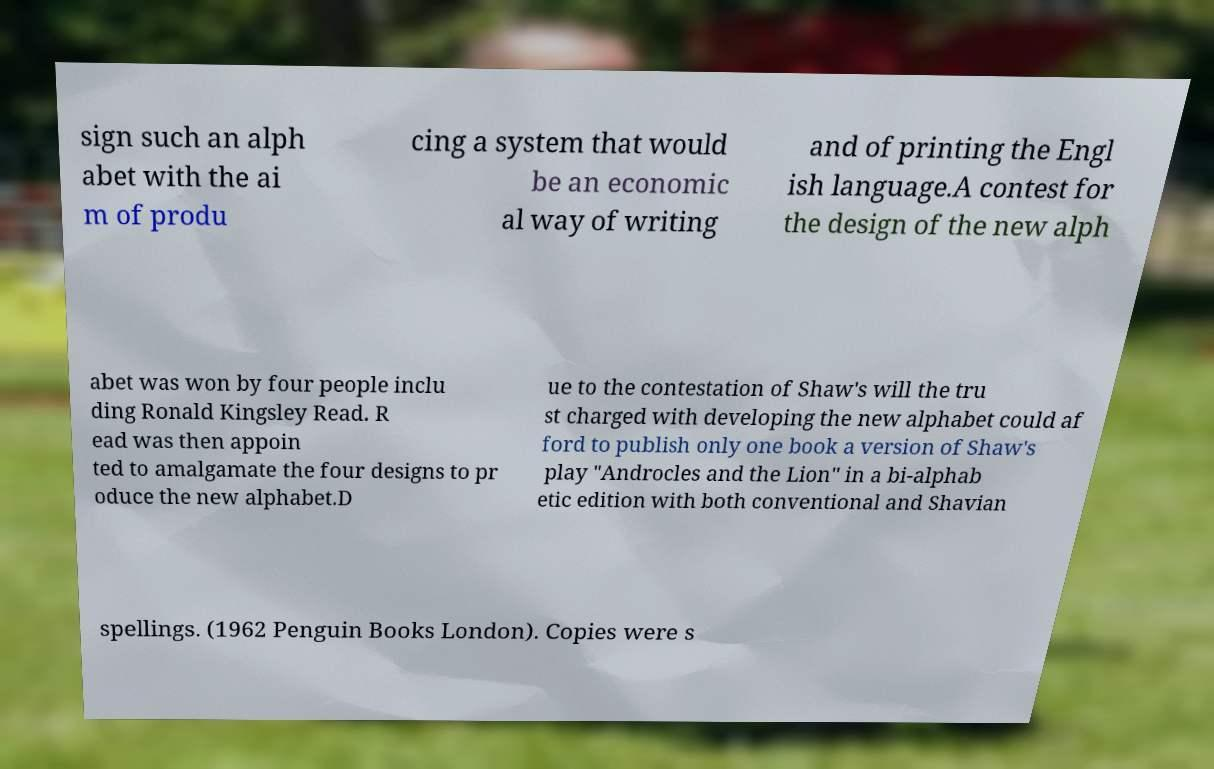Could you extract and type out the text from this image? sign such an alph abet with the ai m of produ cing a system that would be an economic al way of writing and of printing the Engl ish language.A contest for the design of the new alph abet was won by four people inclu ding Ronald Kingsley Read. R ead was then appoin ted to amalgamate the four designs to pr oduce the new alphabet.D ue to the contestation of Shaw's will the tru st charged with developing the new alphabet could af ford to publish only one book a version of Shaw's play "Androcles and the Lion" in a bi-alphab etic edition with both conventional and Shavian spellings. (1962 Penguin Books London). Copies were s 